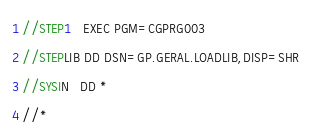<code> <loc_0><loc_0><loc_500><loc_500><_COBOL_>//STEP1   EXEC PGM=CGPRG003
//STEPLIB DD DSN=GP.GERAL.LOADLIB,DISP=SHR
//SYSIN   DD *
//*
</code> 